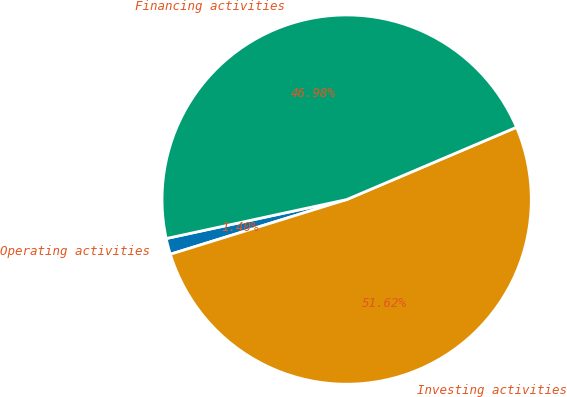<chart> <loc_0><loc_0><loc_500><loc_500><pie_chart><fcel>Operating activities<fcel>Investing activities<fcel>Financing activities<nl><fcel>1.4%<fcel>51.62%<fcel>46.98%<nl></chart> 